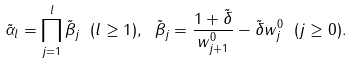<formula> <loc_0><loc_0><loc_500><loc_500>\tilde { \alpha } _ { l } = \prod _ { j = 1 } ^ { l } \tilde { \beta } _ { j } \ ( l \geq 1 ) , \ \tilde { \beta } _ { j } = \frac { 1 + \tilde { \delta } } { w _ { j + 1 } ^ { 0 } } - \tilde { \delta } w _ { j } ^ { 0 } \ ( j \geq 0 ) .</formula> 